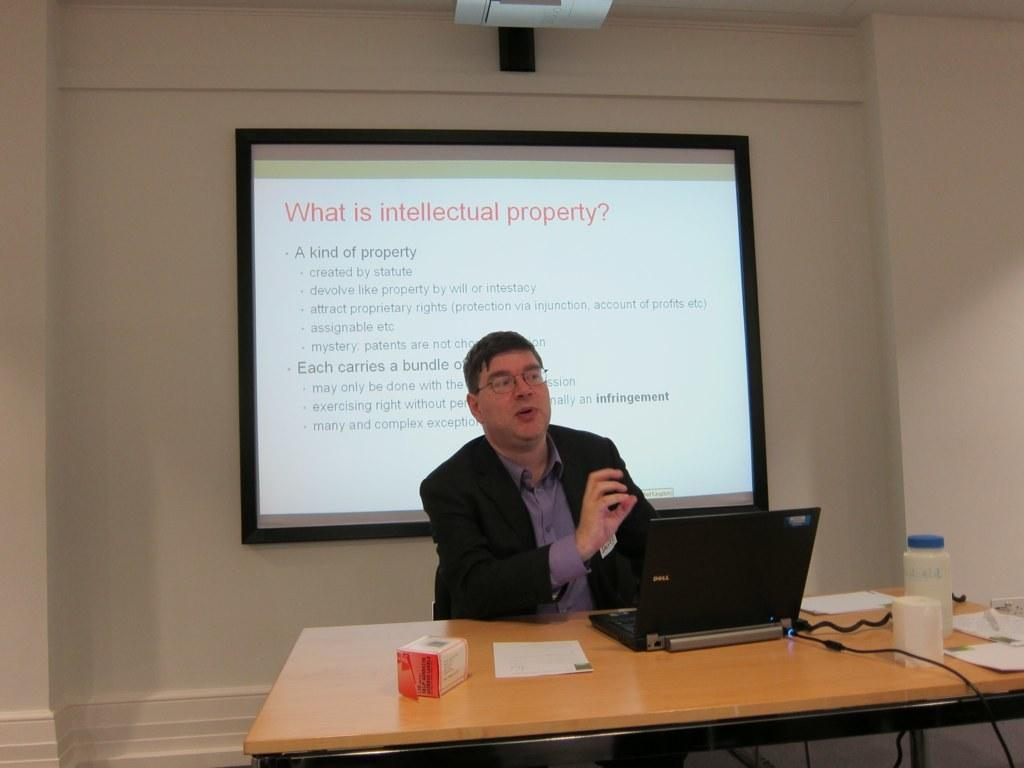What is the main subject of the image? There is a person sitting in the center of the image. What is in front of the person? There is a table in front of the person. What items can be seen on the table? On the table, there is a tab, a paper, a box, glasses, a bottle, and a pen. What can be seen in the background of the image? There is a wall and a screen in the background of the image. What type of polish is being applied to the quiver in the image? There is no polish or quiver present in the image. What class is the person attending in the image? The image does not provide any information about a class or any educational context. 